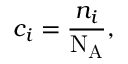Convert formula to latex. <formula><loc_0><loc_0><loc_500><loc_500>c _ { i } = { \frac { n _ { i } } { N _ { A } } } ,</formula> 